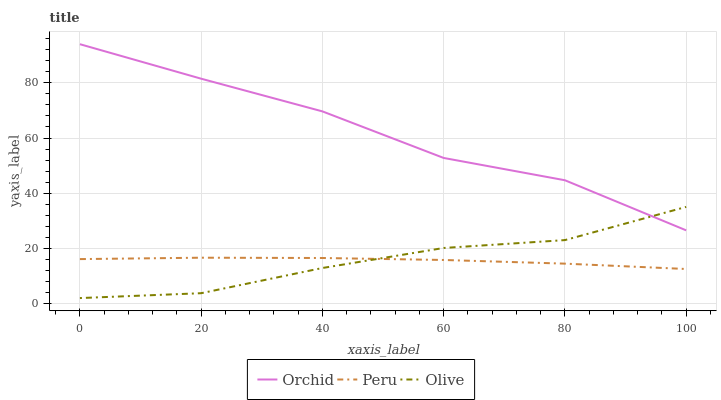Does Peru have the minimum area under the curve?
Answer yes or no. Yes. Does Orchid have the maximum area under the curve?
Answer yes or no. Yes. Does Orchid have the minimum area under the curve?
Answer yes or no. No. Does Peru have the maximum area under the curve?
Answer yes or no. No. Is Peru the smoothest?
Answer yes or no. Yes. Is Orchid the roughest?
Answer yes or no. Yes. Is Orchid the smoothest?
Answer yes or no. No. Is Peru the roughest?
Answer yes or no. No. Does Olive have the lowest value?
Answer yes or no. Yes. Does Peru have the lowest value?
Answer yes or no. No. Does Orchid have the highest value?
Answer yes or no. Yes. Does Peru have the highest value?
Answer yes or no. No. Is Peru less than Orchid?
Answer yes or no. Yes. Is Orchid greater than Peru?
Answer yes or no. Yes. Does Orchid intersect Olive?
Answer yes or no. Yes. Is Orchid less than Olive?
Answer yes or no. No. Is Orchid greater than Olive?
Answer yes or no. No. Does Peru intersect Orchid?
Answer yes or no. No. 